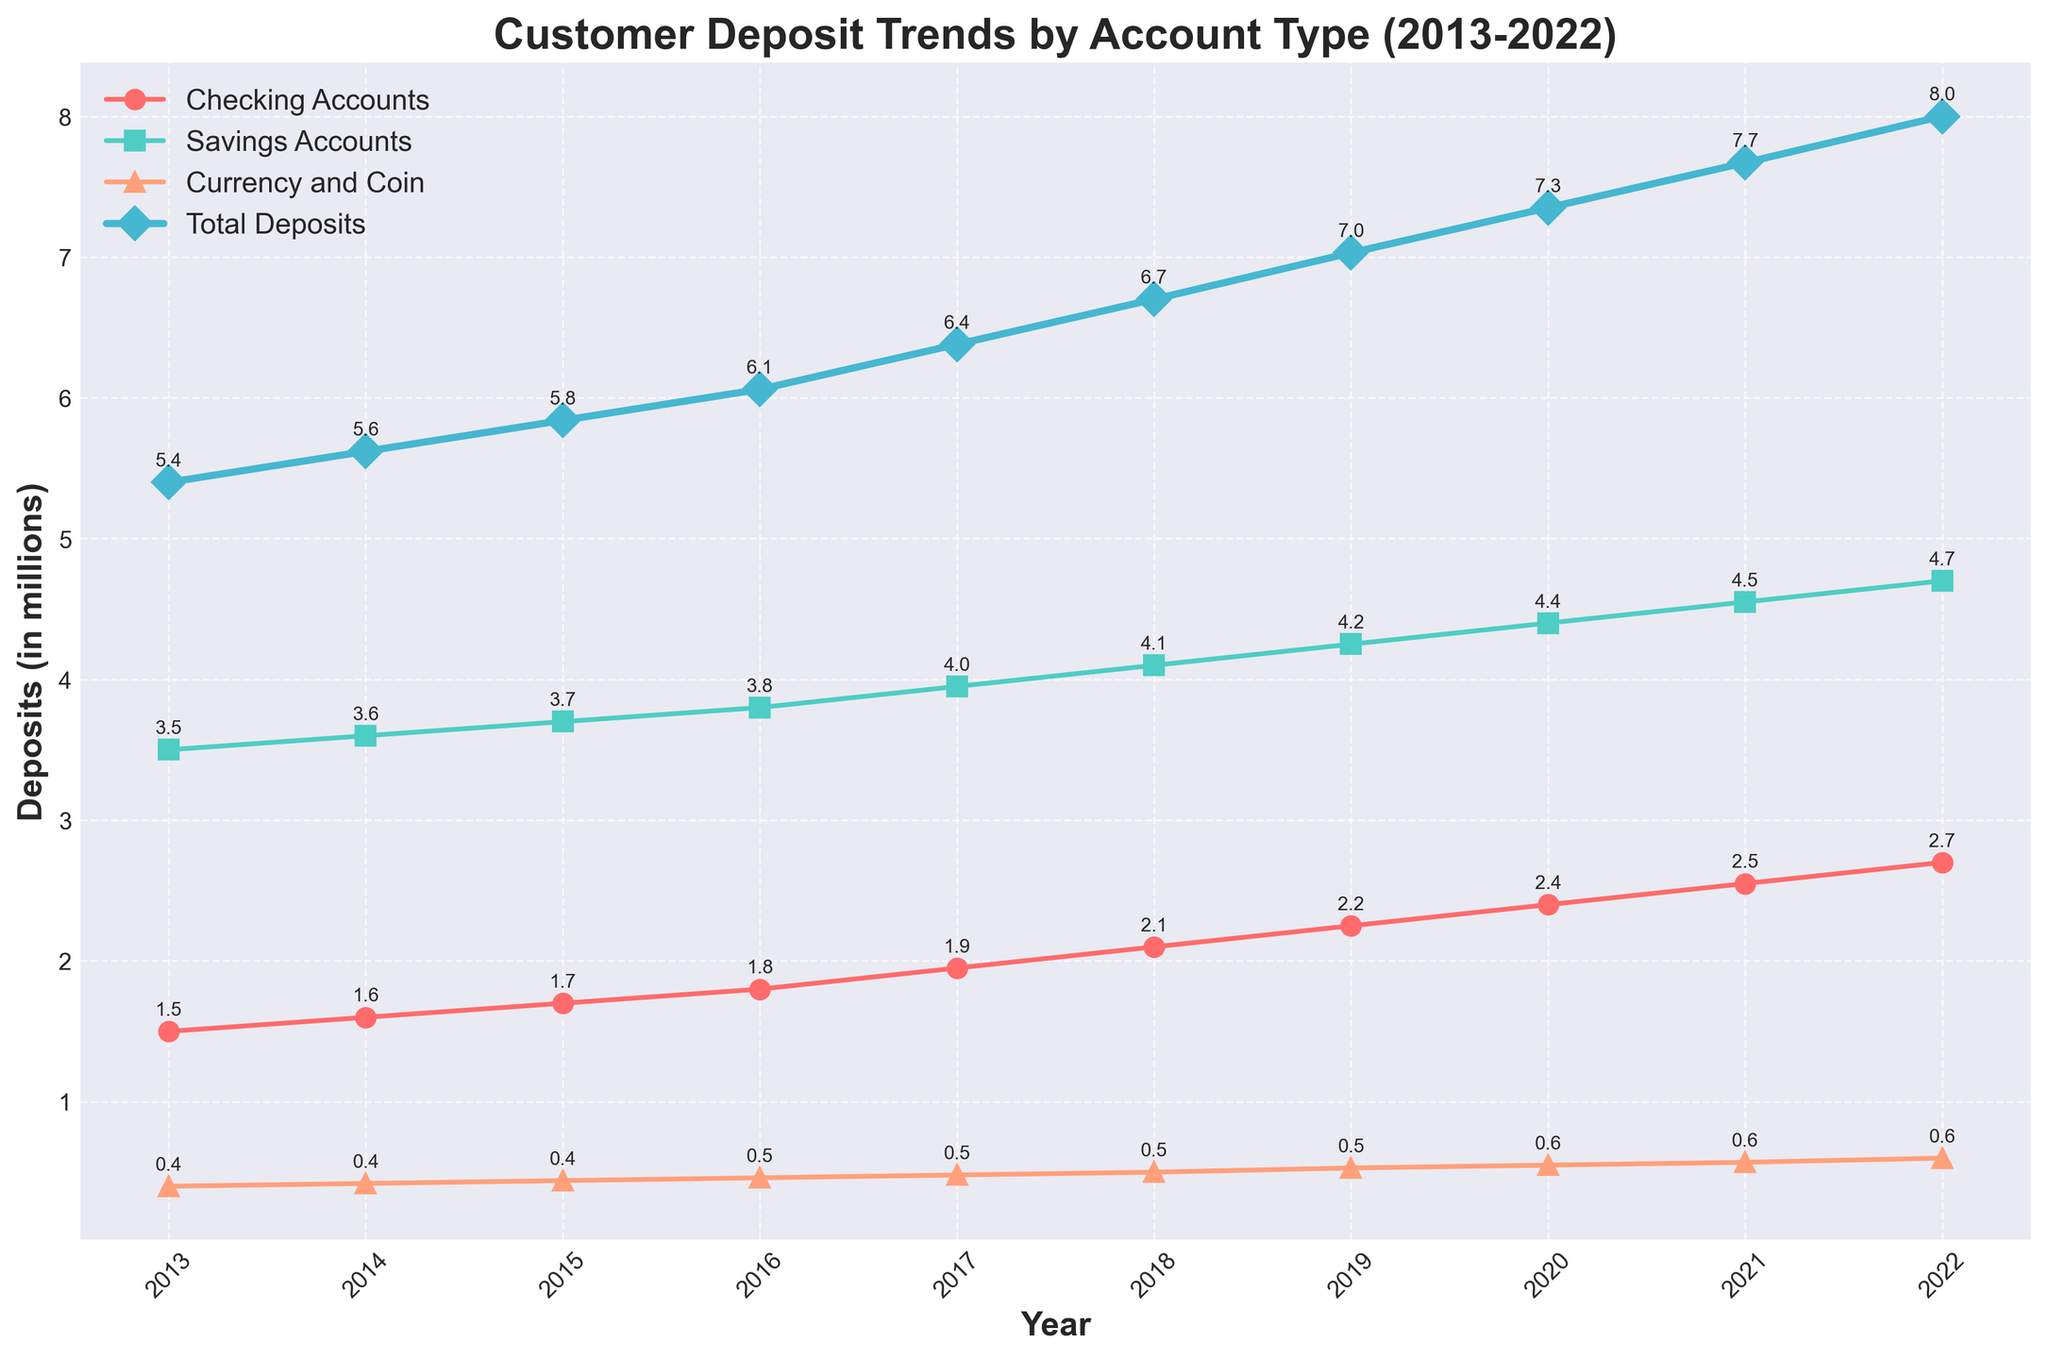What is the title of the figure? The title of the figure is displayed at the top center and reads "Customer Deposit Trends by Account Type (2013-2022)".
Answer: Customer Deposit Trends by Account Type (2013-2022) Which account type had the highest deposit value in 2022? The Savings Accounts had the highest deposit value in 2022, as indicated by the green square marker at the highest vertical position on the plot for that year.
Answer: Savings Accounts What was the total deposit value in 2015? The figure annotates the total deposit value as 5.84 million for the year 2015. This is indicated by the number close to the blue diamond marker on the plot for that year.
Answer: 5.84 million How much did the checking accounts' deposit increase from 2013 to 2022? In 2013, checking accounts had deposits of 1.5 million, and they rose to 2.7 million in 2022. The increase is 2.7 million - 1.5 million = 1.2 million.
Answer: 1.2 million Which year saw the highest increase in total deposits from the previous year? The largest year-over-year increase is between 2021 and 2022. In 2021, the total was 7.67 million, and in 2022 it was 8.00 million. The increase is 8.00 - 7.67 = 0.33 million. The figure shows a notable upward jump between the two years.
Answer: 2022 Are savings accounts generally higher than checking accounts over the decade? Yes, throughout the plot, the line representing savings accounts (indicated by green squares) is consistently above the line representing checking accounts (marked by red circles) each year.
Answer: Yes What was the average deposit value for currency and coin from 2013 to 2022? To find the average, sum the annual values for currency and coin: 0.4 + 0.42 + 0.44 + 0.46 + 0.48 + 0.50 + 0.53 + 0.55 + 0.57 + 0.60 million = 4.95 million. Then, divide this sum by the 10 years, resulting in 4.95/10 = 0.495 million.
Answer: 0.495 million Did any account type ever see a decline in deposit value from one year to the next? The plot shows that all lines representing each account type's deposits (checking accounts, savings accounts, and currency and coin) do not drop at any point. They all show a consistent upward trend.
Answer: No By how much did the total deposits increase from 2013 to 2016? The total deposits in 2013 were 5.4 million, and in 2016, they were 6.06 million. The increase is 6.06 million - 5.4 million = 0.66 million.
Answer: 0.66 million Which account type had the smallest growth over the decade? Currency and coin had the smallest growth. It increased from 0.4 million in 2013 to 0.6 million in 2022. The growth is 0.6 - 0.4 = 0.2 million. This is the smallest increase compared to the other account types.
Answer: Currency and coin 